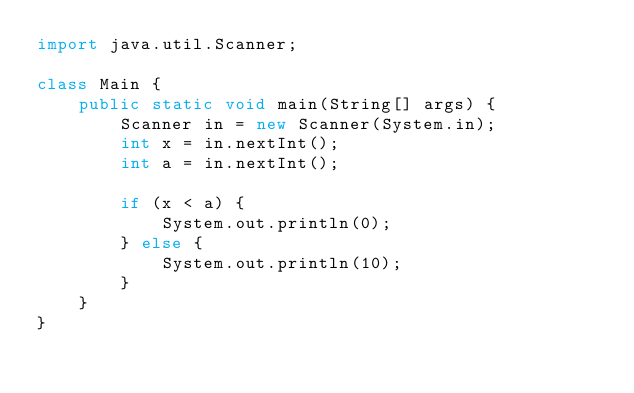<code> <loc_0><loc_0><loc_500><loc_500><_Java_>import java.util.Scanner;

class Main {
    public static void main(String[] args) {
        Scanner in = new Scanner(System.in);
        int x = in.nextInt();
        int a = in.nextInt();
        
        if (x < a) {
            System.out.println(0);
        } else {
            System.out.println(10);
        }
    }
}</code> 